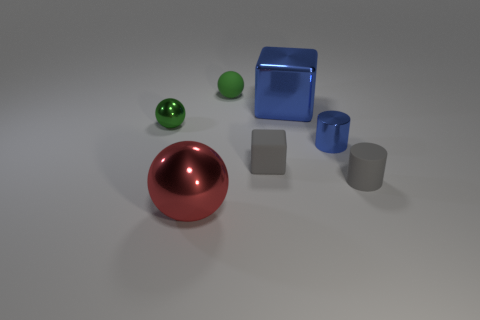There is a thing that is in front of the tiny gray block and left of the small blue metal thing; what is its material?
Your answer should be compact. Metal. There is a green shiny object that is the same size as the green rubber object; what is its shape?
Your response must be concise. Sphere. What is the color of the big metal object to the left of the tiny rubber cube right of the shiny thing that is in front of the blue cylinder?
Your answer should be compact. Red. What number of objects are either blocks in front of the tiny metal cylinder or balls?
Your answer should be very brief. 4. What is the material of the blue cylinder that is the same size as the green shiny thing?
Your response must be concise. Metal. What is the green sphere in front of the large thing that is behind the cube that is on the left side of the big cube made of?
Provide a short and direct response. Metal. The shiny cylinder has what color?
Your response must be concise. Blue. How many tiny things are cylinders or green metallic objects?
Keep it short and to the point. 3. There is a cylinder that is the same color as the shiny cube; what material is it?
Provide a short and direct response. Metal. Do the large thing that is in front of the gray cylinder and the small gray thing that is on the left side of the large metallic cube have the same material?
Give a very brief answer. No. 